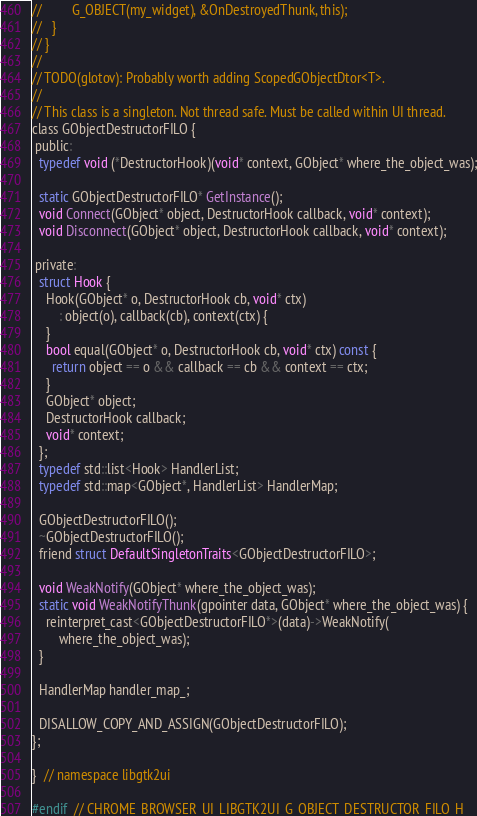Convert code to text. <code><loc_0><loc_0><loc_500><loc_500><_C_>//         G_OBJECT(my_widget), &OnDestroyedThunk, this);
//   }
// }
//
// TODO(glotov): Probably worth adding ScopedGObjectDtor<T>.
//
// This class is a singleton. Not thread safe. Must be called within UI thread.
class GObjectDestructorFILO {
 public:
  typedef void (*DestructorHook)(void* context, GObject* where_the_object_was);

  static GObjectDestructorFILO* GetInstance();
  void Connect(GObject* object, DestructorHook callback, void* context);
  void Disconnect(GObject* object, DestructorHook callback, void* context);

 private:
  struct Hook {
    Hook(GObject* o, DestructorHook cb, void* ctx)
        : object(o), callback(cb), context(ctx) {
    }
    bool equal(GObject* o, DestructorHook cb, void* ctx) const {
      return object == o && callback == cb && context == ctx;
    }
    GObject* object;
    DestructorHook callback;
    void* context;
  };
  typedef std::list<Hook> HandlerList;
  typedef std::map<GObject*, HandlerList> HandlerMap;

  GObjectDestructorFILO();
  ~GObjectDestructorFILO();
  friend struct DefaultSingletonTraits<GObjectDestructorFILO>;

  void WeakNotify(GObject* where_the_object_was);
  static void WeakNotifyThunk(gpointer data, GObject* where_the_object_was) {
    reinterpret_cast<GObjectDestructorFILO*>(data)->WeakNotify(
        where_the_object_was);
  }

  HandlerMap handler_map_;

  DISALLOW_COPY_AND_ASSIGN(GObjectDestructorFILO);
};

}  // namespace libgtk2ui

#endif  // CHROME_BROWSER_UI_LIBGTK2UI_G_OBJECT_DESTRUCTOR_FILO_H_
</code> 